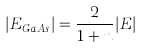<formula> <loc_0><loc_0><loc_500><loc_500>| E _ { G a A s } | = \frac { 2 } { 1 + n } | E |</formula> 